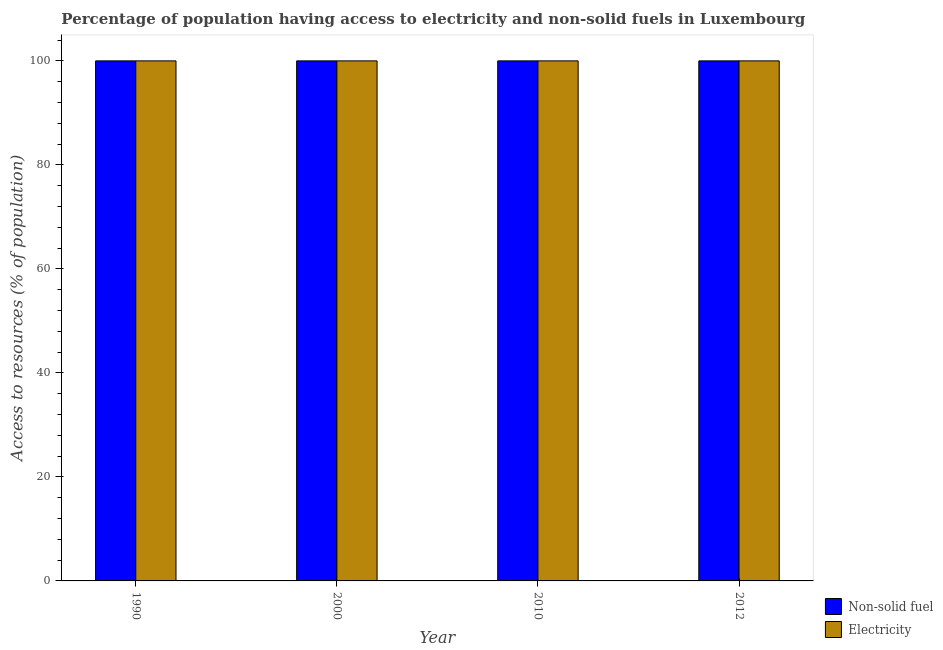Are the number of bars per tick equal to the number of legend labels?
Provide a succinct answer. Yes. How many bars are there on the 2nd tick from the right?
Ensure brevity in your answer.  2. In how many cases, is the number of bars for a given year not equal to the number of legend labels?
Ensure brevity in your answer.  0. What is the percentage of population having access to electricity in 2012?
Offer a terse response. 100. Across all years, what is the maximum percentage of population having access to non-solid fuel?
Ensure brevity in your answer.  100. Across all years, what is the minimum percentage of population having access to non-solid fuel?
Provide a short and direct response. 100. In which year was the percentage of population having access to non-solid fuel maximum?
Keep it short and to the point. 1990. In which year was the percentage of population having access to electricity minimum?
Give a very brief answer. 1990. What is the total percentage of population having access to electricity in the graph?
Your answer should be compact. 400. What is the difference between the percentage of population having access to electricity in 2000 and that in 2010?
Make the answer very short. 0. In how many years, is the percentage of population having access to electricity greater than 44 %?
Keep it short and to the point. 4. Is the percentage of population having access to electricity in 2010 less than that in 2012?
Make the answer very short. No. Is the difference between the percentage of population having access to non-solid fuel in 2010 and 2012 greater than the difference between the percentage of population having access to electricity in 2010 and 2012?
Make the answer very short. No. What is the difference between the highest and the second highest percentage of population having access to non-solid fuel?
Offer a very short reply. 0. What is the difference between the highest and the lowest percentage of population having access to non-solid fuel?
Your response must be concise. 0. In how many years, is the percentage of population having access to electricity greater than the average percentage of population having access to electricity taken over all years?
Provide a succinct answer. 0. Is the sum of the percentage of population having access to electricity in 1990 and 2000 greater than the maximum percentage of population having access to non-solid fuel across all years?
Your response must be concise. Yes. What does the 2nd bar from the left in 2012 represents?
Ensure brevity in your answer.  Electricity. What does the 1st bar from the right in 2000 represents?
Keep it short and to the point. Electricity. Are all the bars in the graph horizontal?
Offer a very short reply. No. How many years are there in the graph?
Keep it short and to the point. 4. What is the difference between two consecutive major ticks on the Y-axis?
Keep it short and to the point. 20. Are the values on the major ticks of Y-axis written in scientific E-notation?
Ensure brevity in your answer.  No. Does the graph contain any zero values?
Your response must be concise. No. Where does the legend appear in the graph?
Offer a terse response. Bottom right. How many legend labels are there?
Provide a short and direct response. 2. What is the title of the graph?
Your response must be concise. Percentage of population having access to electricity and non-solid fuels in Luxembourg. Does "Nitrous oxide emissions" appear as one of the legend labels in the graph?
Offer a very short reply. No. What is the label or title of the Y-axis?
Your answer should be compact. Access to resources (% of population). What is the Access to resources (% of population) of Non-solid fuel in 1990?
Provide a succinct answer. 100. What is the Access to resources (% of population) in Electricity in 2000?
Give a very brief answer. 100. What is the Access to resources (% of population) in Electricity in 2010?
Provide a succinct answer. 100. Across all years, what is the minimum Access to resources (% of population) of Electricity?
Make the answer very short. 100. What is the total Access to resources (% of population) in Non-solid fuel in the graph?
Keep it short and to the point. 400. What is the difference between the Access to resources (% of population) of Non-solid fuel in 1990 and that in 2012?
Your answer should be very brief. 0. What is the difference between the Access to resources (% of population) of Non-solid fuel in 2000 and that in 2010?
Your answer should be very brief. 0. What is the difference between the Access to resources (% of population) in Non-solid fuel in 2000 and that in 2012?
Your answer should be compact. 0. What is the difference between the Access to resources (% of population) of Non-solid fuel in 2010 and the Access to resources (% of population) of Electricity in 2012?
Keep it short and to the point. 0. In the year 1990, what is the difference between the Access to resources (% of population) of Non-solid fuel and Access to resources (% of population) of Electricity?
Offer a terse response. 0. In the year 2000, what is the difference between the Access to resources (% of population) in Non-solid fuel and Access to resources (% of population) in Electricity?
Your response must be concise. 0. In the year 2010, what is the difference between the Access to resources (% of population) of Non-solid fuel and Access to resources (% of population) of Electricity?
Provide a succinct answer. 0. In the year 2012, what is the difference between the Access to resources (% of population) in Non-solid fuel and Access to resources (% of population) in Electricity?
Offer a very short reply. 0. What is the ratio of the Access to resources (% of population) of Non-solid fuel in 1990 to that in 2010?
Ensure brevity in your answer.  1. What is the ratio of the Access to resources (% of population) of Non-solid fuel in 1990 to that in 2012?
Offer a terse response. 1. What is the ratio of the Access to resources (% of population) of Non-solid fuel in 2000 to that in 2010?
Provide a succinct answer. 1. What is the ratio of the Access to resources (% of population) of Electricity in 2000 to that in 2010?
Give a very brief answer. 1. What is the ratio of the Access to resources (% of population) in Non-solid fuel in 2000 to that in 2012?
Provide a succinct answer. 1. What is the ratio of the Access to resources (% of population) in Electricity in 2010 to that in 2012?
Your response must be concise. 1. What is the difference between the highest and the second highest Access to resources (% of population) of Electricity?
Offer a terse response. 0. What is the difference between the highest and the lowest Access to resources (% of population) of Non-solid fuel?
Offer a terse response. 0. What is the difference between the highest and the lowest Access to resources (% of population) in Electricity?
Provide a short and direct response. 0. 